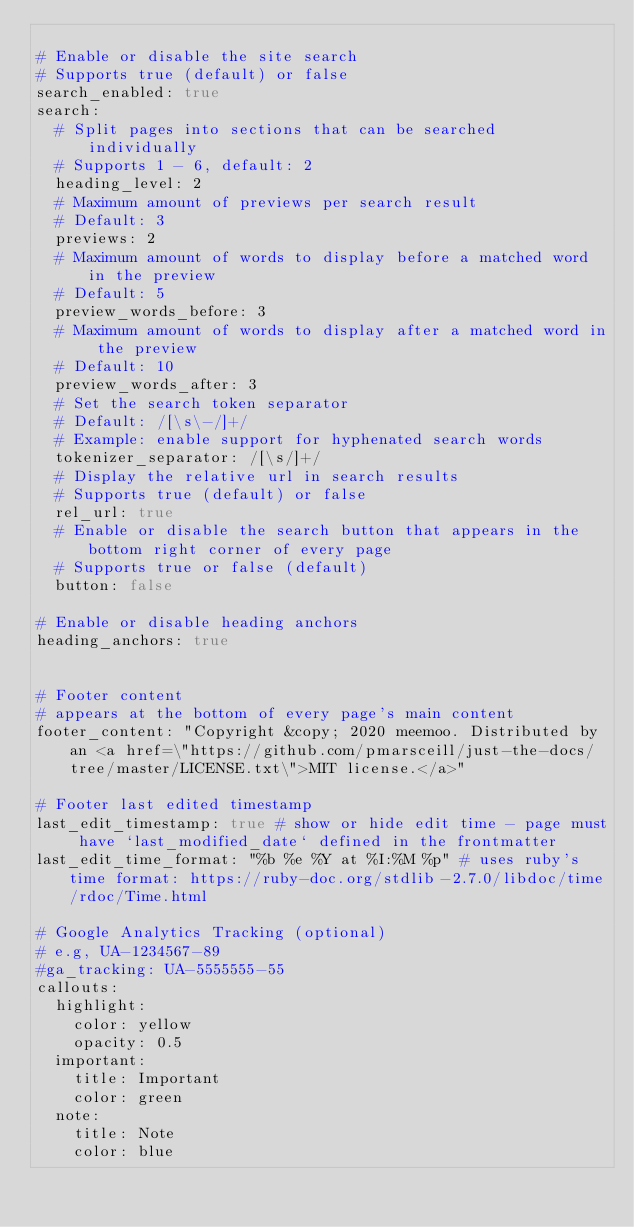Convert code to text. <code><loc_0><loc_0><loc_500><loc_500><_YAML_>
# Enable or disable the site search
# Supports true (default) or false
search_enabled: true
search:
  # Split pages into sections that can be searched individually
  # Supports 1 - 6, default: 2
  heading_level: 2
  # Maximum amount of previews per search result
  # Default: 3
  previews: 2
  # Maximum amount of words to display before a matched word in the preview
  # Default: 5
  preview_words_before: 3
  # Maximum amount of words to display after a matched word in the preview
  # Default: 10
  preview_words_after: 3
  # Set the search token separator
  # Default: /[\s\-/]+/
  # Example: enable support for hyphenated search words
  tokenizer_separator: /[\s/]+/
  # Display the relative url in search results
  # Supports true (default) or false
  rel_url: true
  # Enable or disable the search button that appears in the bottom right corner of every page
  # Supports true or false (default)
  button: false

# Enable or disable heading anchors
heading_anchors: true


# Footer content 
# appears at the bottom of every page's main content
footer_content: "Copyright &copy; 2020 meemoo. Distributed by an <a href=\"https://github.com/pmarsceill/just-the-docs/tree/master/LICENSE.txt\">MIT license.</a>"

# Footer last edited timestamp
last_edit_timestamp: true # show or hide edit time - page must have `last_modified_date` defined in the frontmatter
last_edit_time_format: "%b %e %Y at %I:%M %p" # uses ruby's time format: https://ruby-doc.org/stdlib-2.7.0/libdoc/time/rdoc/Time.html

# Google Analytics Tracking (optional)
# e.g, UA-1234567-89
#ga_tracking: UA-5555555-55
callouts:
  highlight:
    color: yellow
    opacity: 0.5
  important:
    title: Important
    color: green
  note:
    title: Note
    color: blue
</code> 